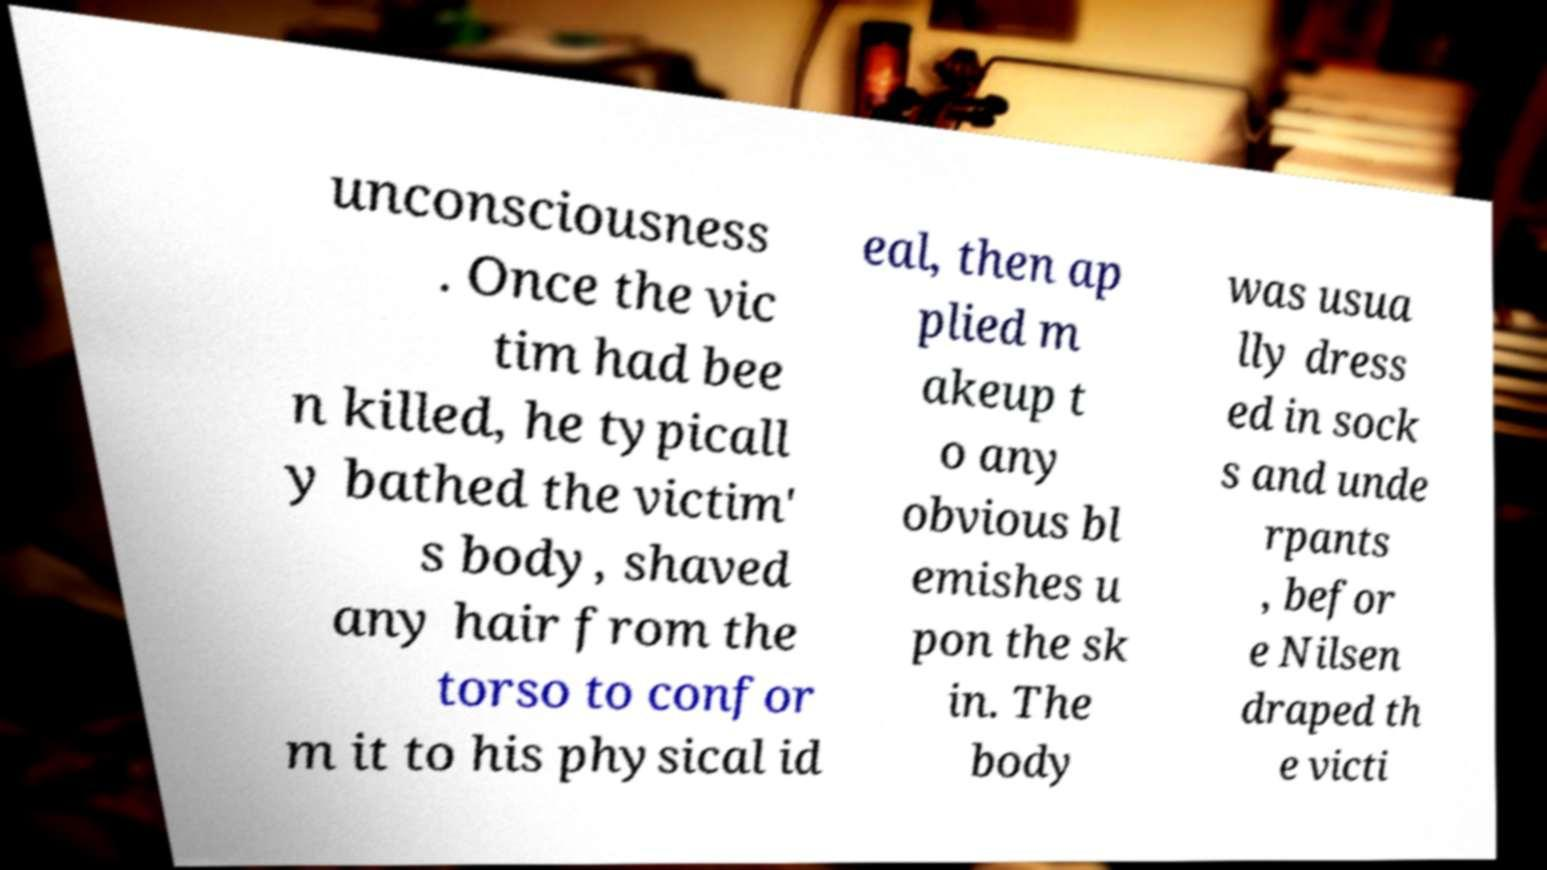Please read and relay the text visible in this image. What does it say? unconsciousness . Once the vic tim had bee n killed, he typicall y bathed the victim' s body, shaved any hair from the torso to confor m it to his physical id eal, then ap plied m akeup t o any obvious bl emishes u pon the sk in. The body was usua lly dress ed in sock s and unde rpants , befor e Nilsen draped th e victi 